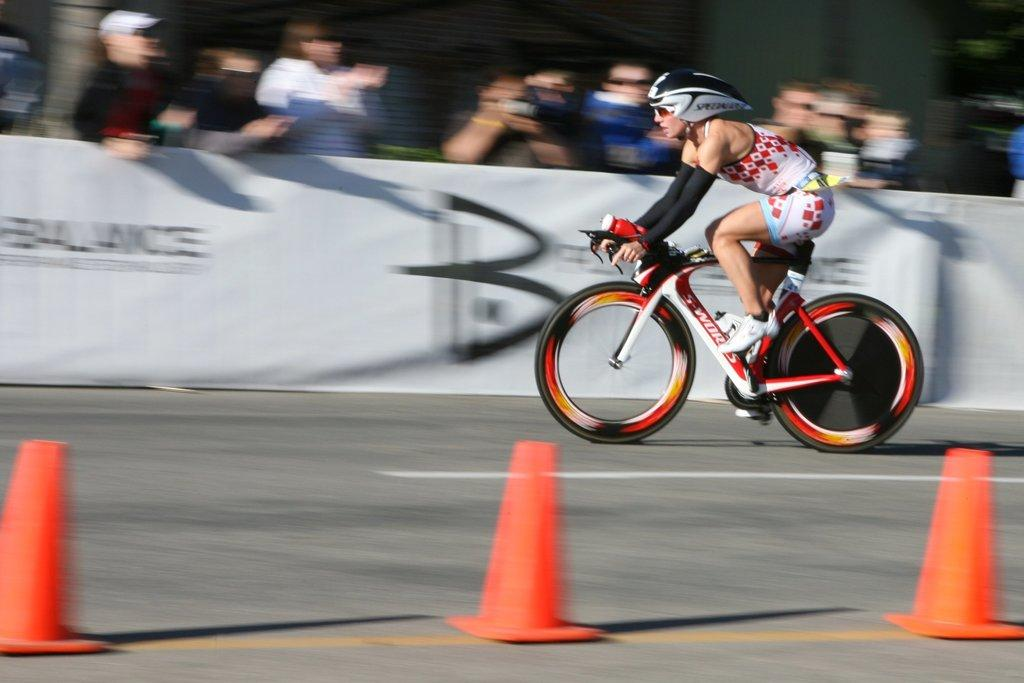Who is the main subject in the image? There is a woman in the image. What is the woman doing in the image? The woman is riding a bicycle. What type of event is taking place in the image? The event is a sports event. What type of beef is being served at the sports event in the image? There is no mention of beef or any food being served in the image. The focus is on the woman riding a bicycle during a sports event. 